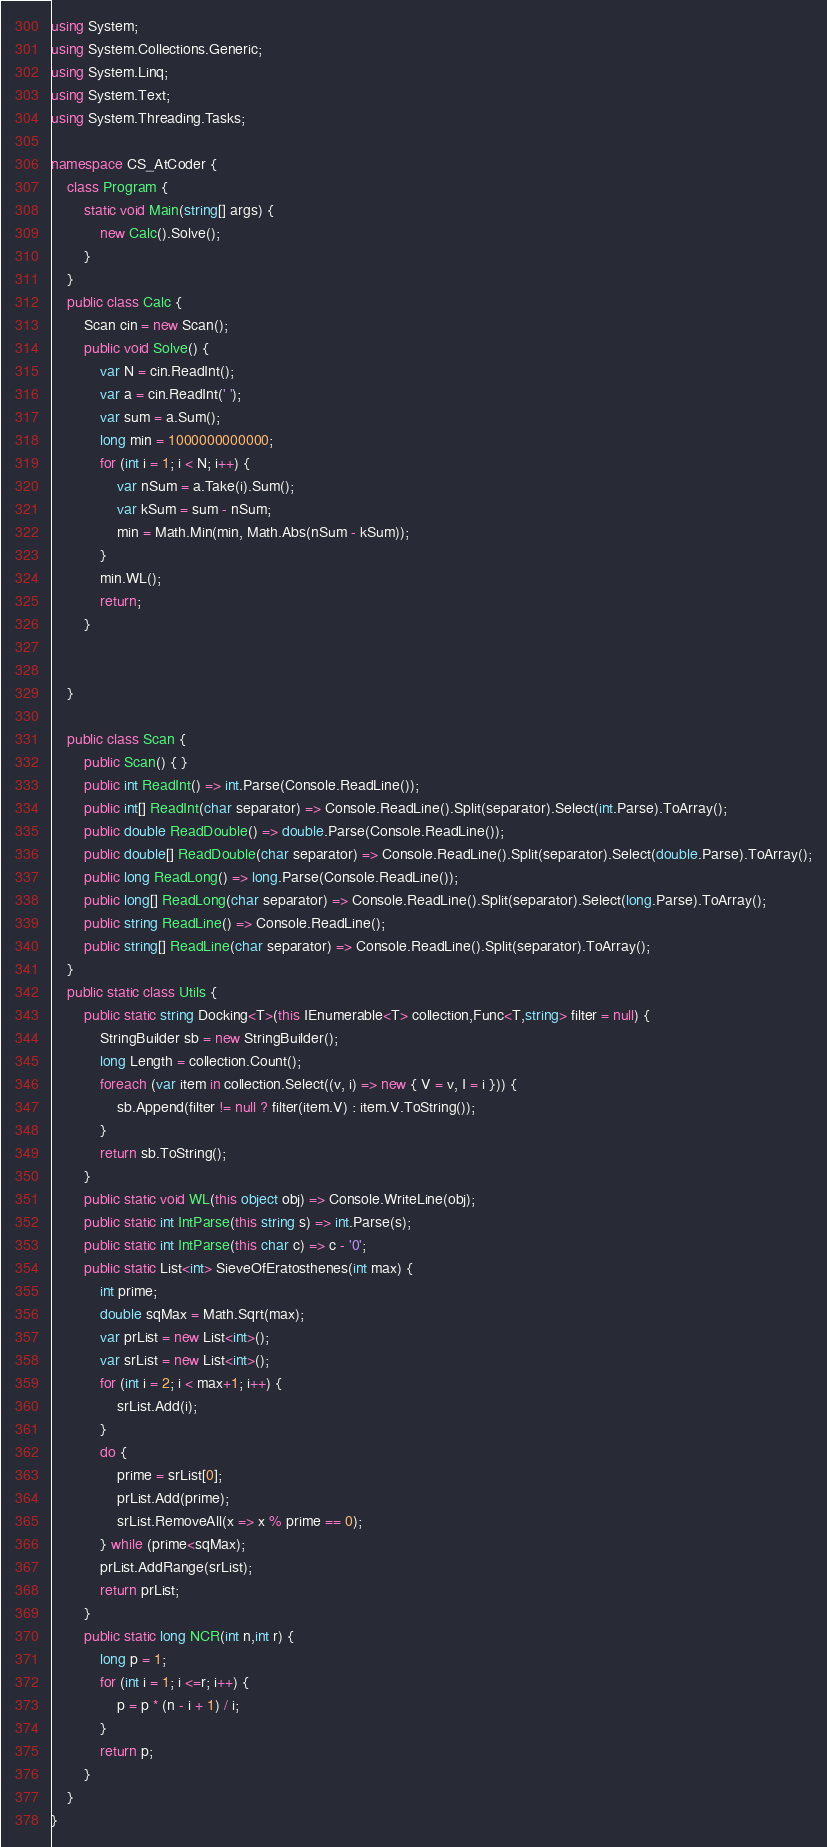Convert code to text. <code><loc_0><loc_0><loc_500><loc_500><_C#_>using System;
using System.Collections.Generic;
using System.Linq;
using System.Text;
using System.Threading.Tasks;

namespace CS_AtCoder {
	class Program {
		static void Main(string[] args) {
			new Calc().Solve();
		}
	}
	public class Calc {
		Scan cin = new Scan();
		public void Solve() {
			var N = cin.ReadInt();
			var a = cin.ReadInt(' ');
			var sum = a.Sum();
			long min = 1000000000000;
			for (int i = 1; i < N; i++) {
				var nSum = a.Take(i).Sum();
				var kSum = sum - nSum;
				min = Math.Min(min, Math.Abs(nSum - kSum));
			}
			min.WL();
			return;
		}


	}

	public class Scan {
		public Scan() { }
		public int ReadInt() => int.Parse(Console.ReadLine());
		public int[] ReadInt(char separator) => Console.ReadLine().Split(separator).Select(int.Parse).ToArray();
		public double ReadDouble() => double.Parse(Console.ReadLine());
		public double[] ReadDouble(char separator) => Console.ReadLine().Split(separator).Select(double.Parse).ToArray();
		public long ReadLong() => long.Parse(Console.ReadLine());
		public long[] ReadLong(char separator) => Console.ReadLine().Split(separator).Select(long.Parse).ToArray();
		public string ReadLine() => Console.ReadLine();
		public string[] ReadLine(char separator) => Console.ReadLine().Split(separator).ToArray();
	}
	public static class Utils {
		public static string Docking<T>(this IEnumerable<T> collection,Func<T,string> filter = null) {
			StringBuilder sb = new StringBuilder();
			long Length = collection.Count();
			foreach (var item in collection.Select((v, i) => new { V = v, I = i })) {
				sb.Append(filter != null ? filter(item.V) : item.V.ToString());
			}
			return sb.ToString();
		}
		public static void WL(this object obj) => Console.WriteLine(obj);
		public static int IntParse(this string s) => int.Parse(s);
		public static int IntParse(this char c) => c - '0';
		public static List<int> SieveOfEratosthenes(int max) {
			int prime;
			double sqMax = Math.Sqrt(max);
			var prList = new List<int>();
			var srList = new List<int>();
			for (int i = 2; i < max+1; i++) {
				srList.Add(i);
			}
			do {
				prime = srList[0];
				prList.Add(prime);
				srList.RemoveAll(x => x % prime == 0);
			} while (prime<sqMax);
			prList.AddRange(srList);
			return prList;
		}
		public static long NCR(int n,int r) {
			long p = 1;
			for (int i = 1; i <=r; i++) {
				p = p * (n - i + 1) / i;
			}
			return p;
		}
	}
}
</code> 